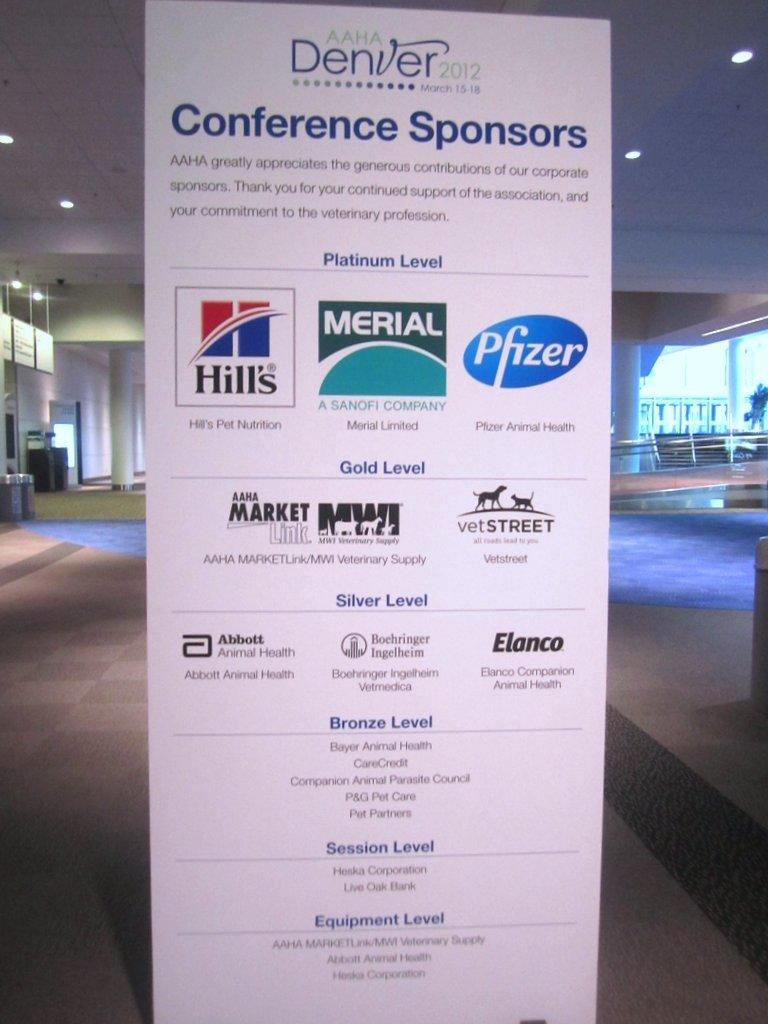<image>
Share a concise interpretation of the image provided. A display sign shows the conference sponsors for the 2012 Denver AAHA conference. 